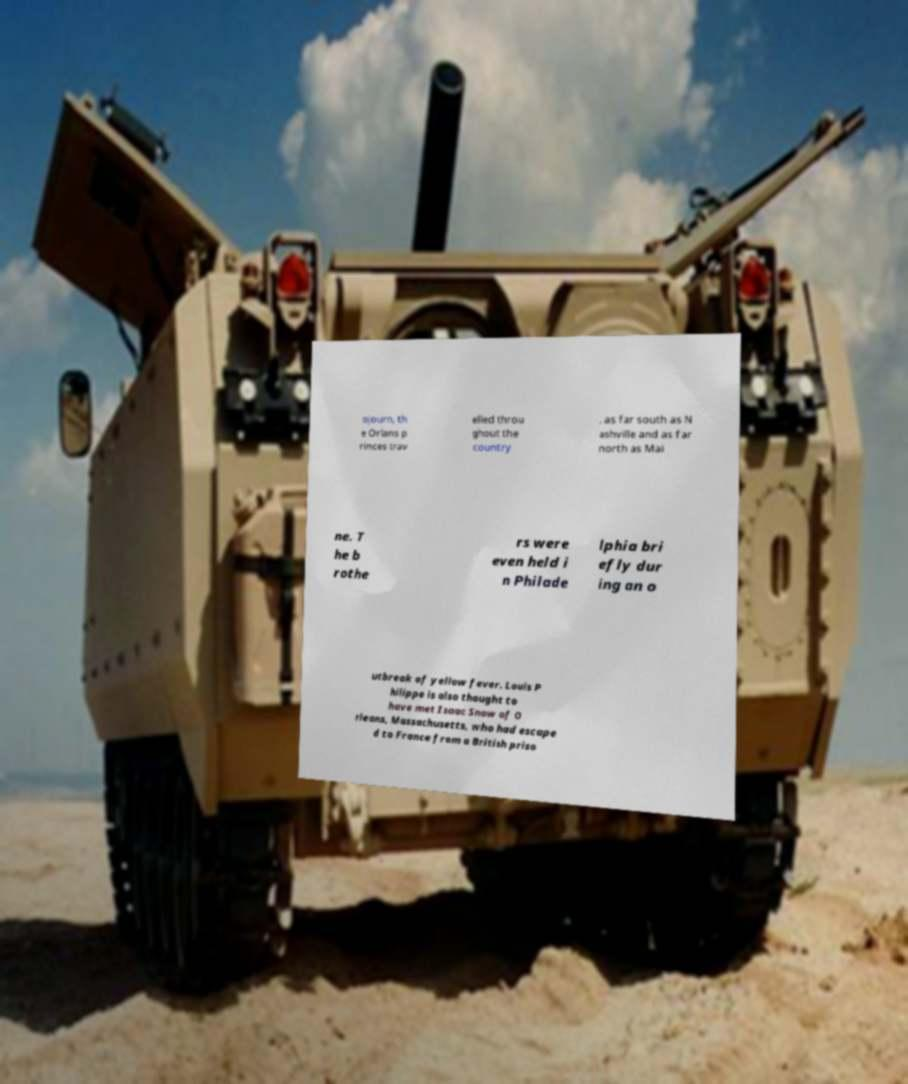Can you accurately transcribe the text from the provided image for me? ojourn, th e Orlans p rinces trav elled throu ghout the country , as far south as N ashville and as far north as Mai ne. T he b rothe rs were even held i n Philade lphia bri efly dur ing an o utbreak of yellow fever. Louis P hilippe is also thought to have met Isaac Snow of O rleans, Massachusetts, who had escape d to France from a British priso 